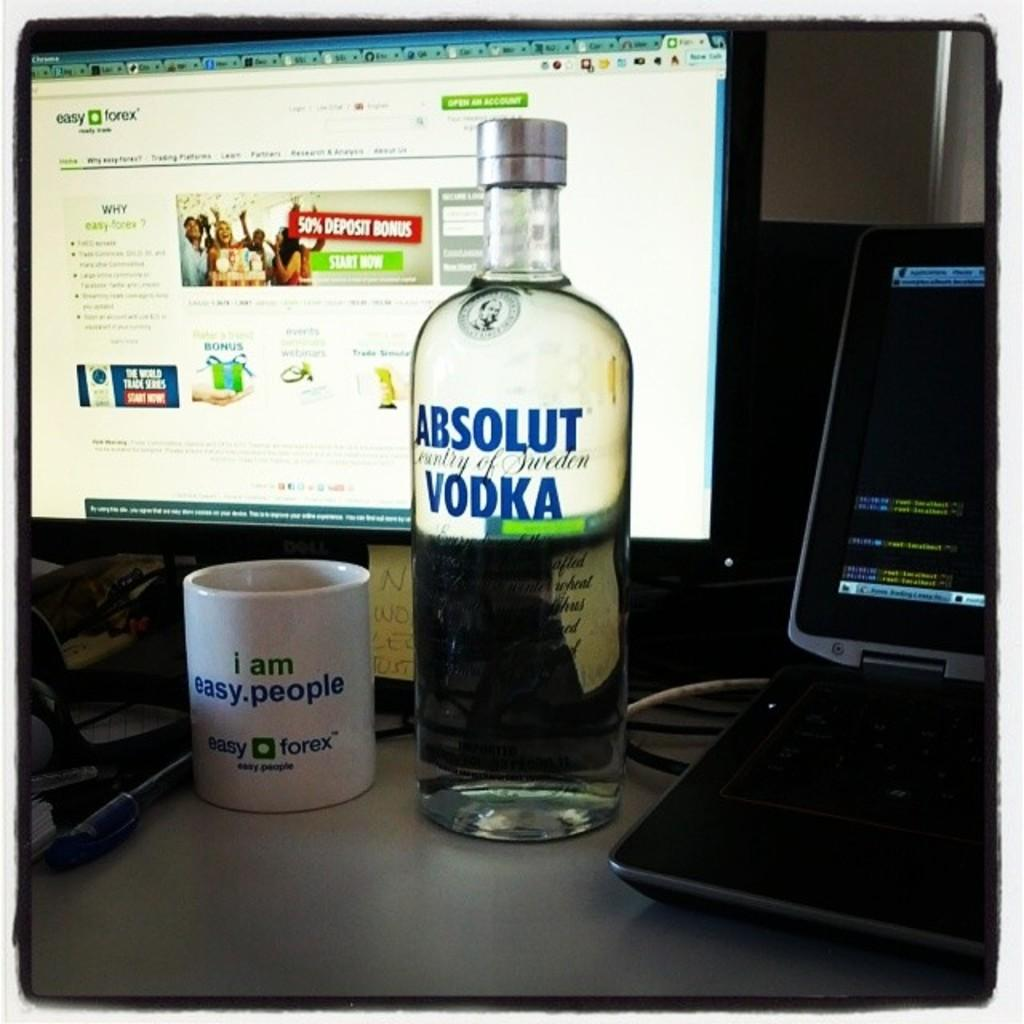<image>
Render a clear and concise summary of the photo. A bottle of Absolut Vodka sitting next to a coffee mug on a table with a computer monitor on behind it. 